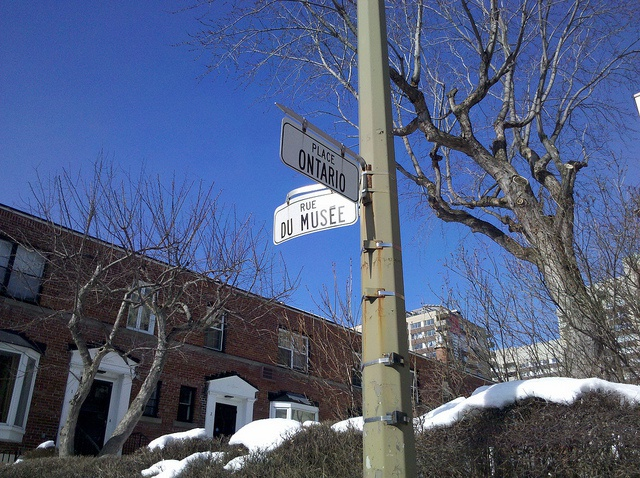Describe the objects in this image and their specific colors. I can see various objects in this image with different colors. 